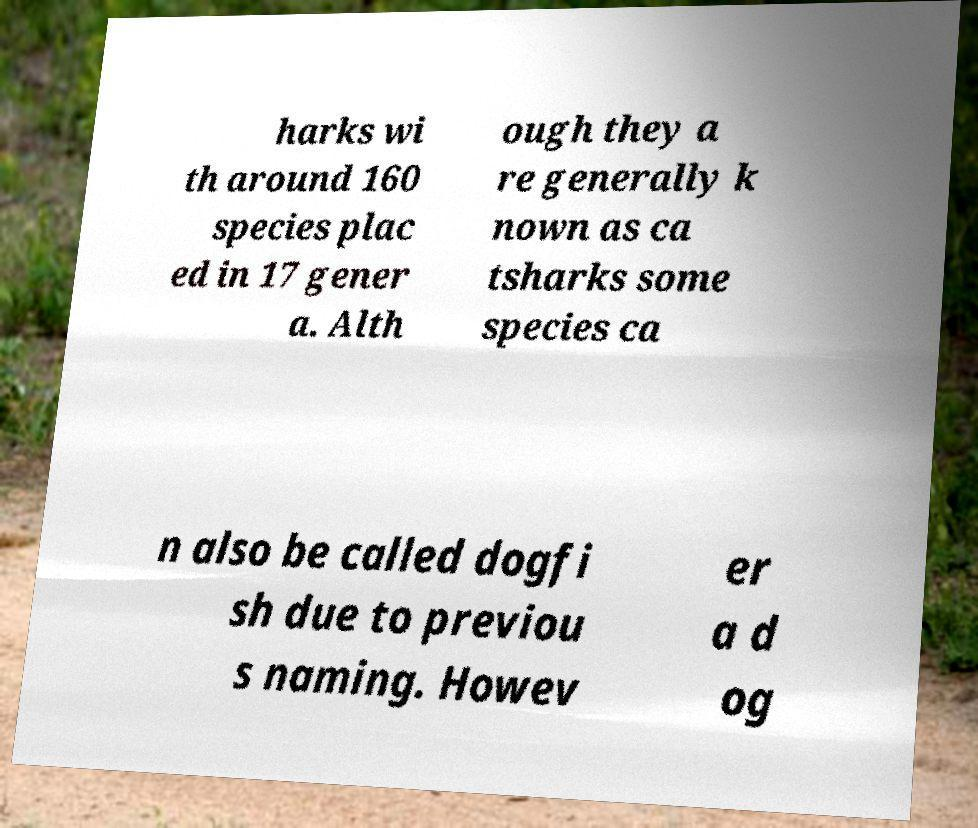Please identify and transcribe the text found in this image. harks wi th around 160 species plac ed in 17 gener a. Alth ough they a re generally k nown as ca tsharks some species ca n also be called dogfi sh due to previou s naming. Howev er a d og 